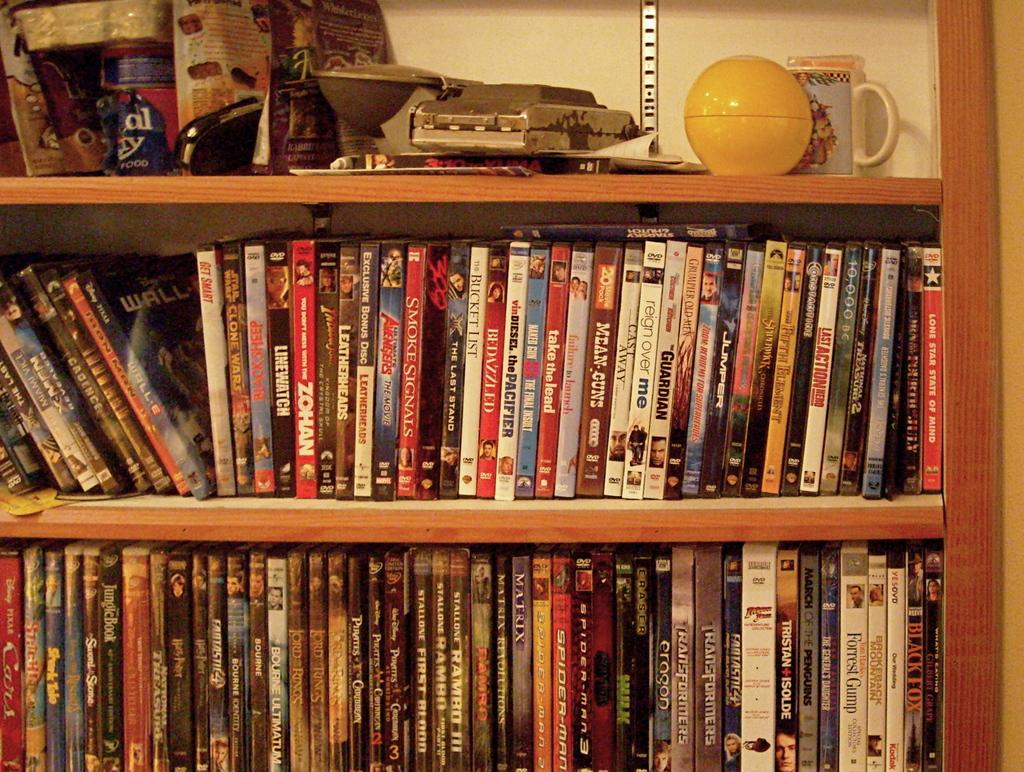Do they have "reign over me"?
Offer a very short reply. Yes. Are there any disney pixar movies?
Provide a short and direct response. Yes. 